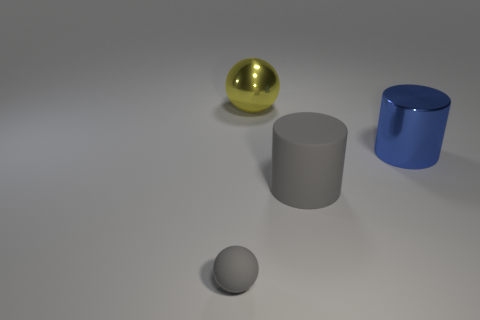Do the matte object behind the gray sphere and the tiny object have the same color?
Your answer should be very brief. Yes. There is a gray rubber thing that is right of the yellow sphere; is it the same size as the small matte ball?
Keep it short and to the point. No. What size is the cylinder that is the same color as the matte ball?
Your response must be concise. Large. Do the cylinder that is on the left side of the shiny cylinder and the ball in front of the blue cylinder have the same color?
Your answer should be very brief. Yes. Is there a matte ball that has the same color as the big matte thing?
Keep it short and to the point. Yes. There is a object that is in front of the big blue thing and behind the gray sphere; how big is it?
Offer a terse response. Large. Is there anything else that is the same color as the large sphere?
Make the answer very short. No. What is the shape of the tiny gray object?
Provide a short and direct response. Sphere. There is a thing that is made of the same material as the small sphere; what color is it?
Your answer should be very brief. Gray. Is the number of yellow matte cubes greater than the number of small gray objects?
Give a very brief answer. No. 